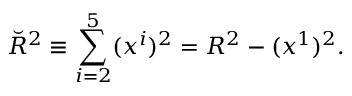<formula> <loc_0><loc_0><loc_500><loc_500>\breve { R } ^ { 2 } \equiv \sum _ { i = 2 } ^ { 5 } ( x ^ { i } ) ^ { 2 } = R ^ { 2 } - ( x ^ { 1 } ) ^ { 2 } .</formula> 